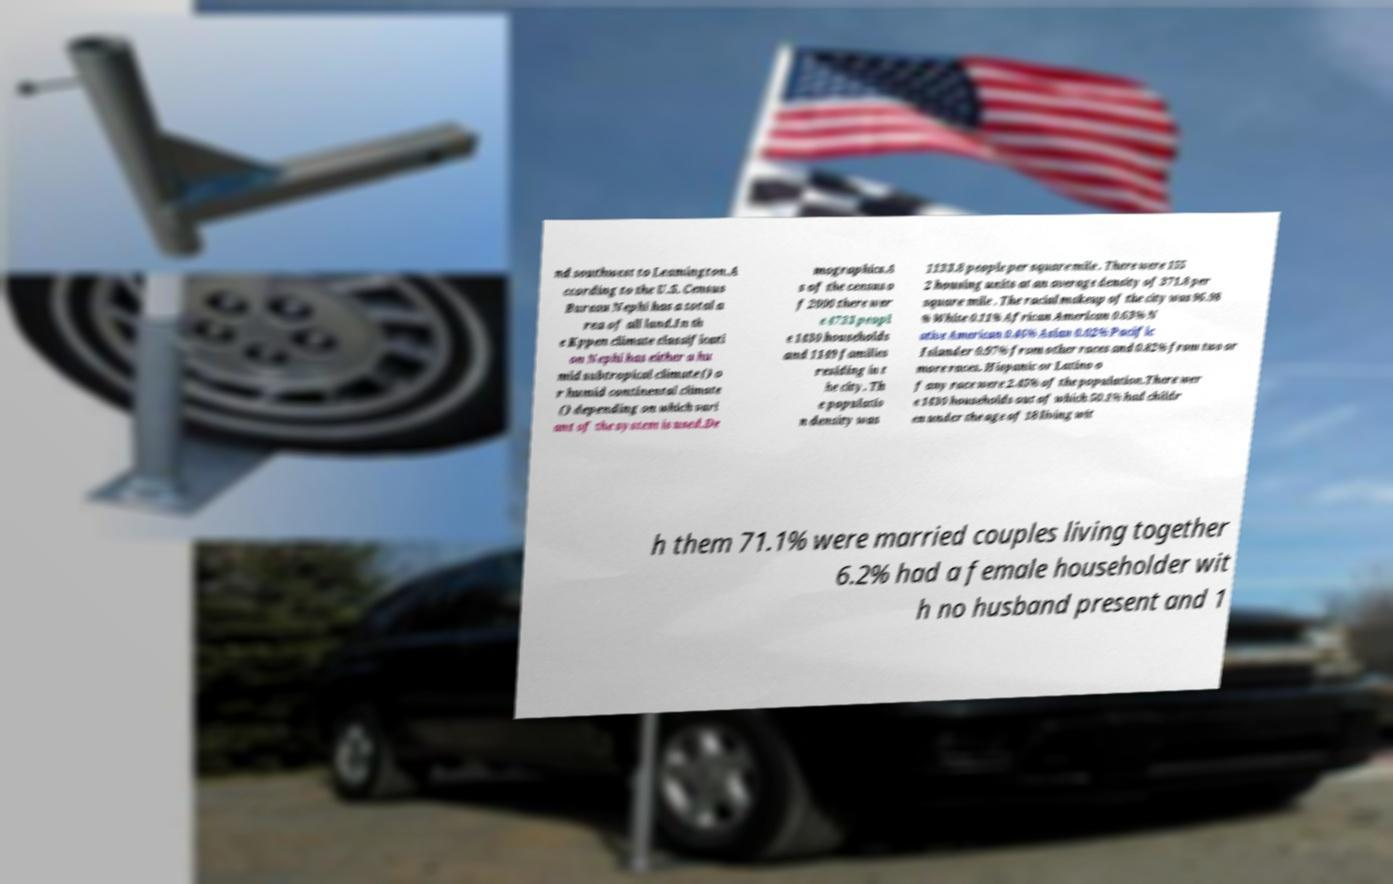Please read and relay the text visible in this image. What does it say? nd southwest to Leamington.A ccording to the U.S. Census Bureau Nephi has a total a rea of all land.In th e Kppen climate classificati on Nephi has either a hu mid subtropical climate () o r humid continental climate () depending on which vari ant of the system is used.De mographics.A s of the census o f 2000 there wer e 4733 peopl e 1430 households and 1149 families residing in t he city. Th e populatio n density was 1133.8 people per square mile . There were 155 2 housing units at an average density of 371.8 per square mile . The racial makeup of the city was 96.98 % White 0.11% African American 0.63% N ative American 0.46% Asian 0.02% Pacific Islander 0.97% from other races and 0.82% from two or more races. Hispanic or Latino o f any race were 2.45% of the population.There wer e 1430 households out of which 50.1% had childr en under the age of 18 living wit h them 71.1% were married couples living together 6.2% had a female householder wit h no husband present and 1 